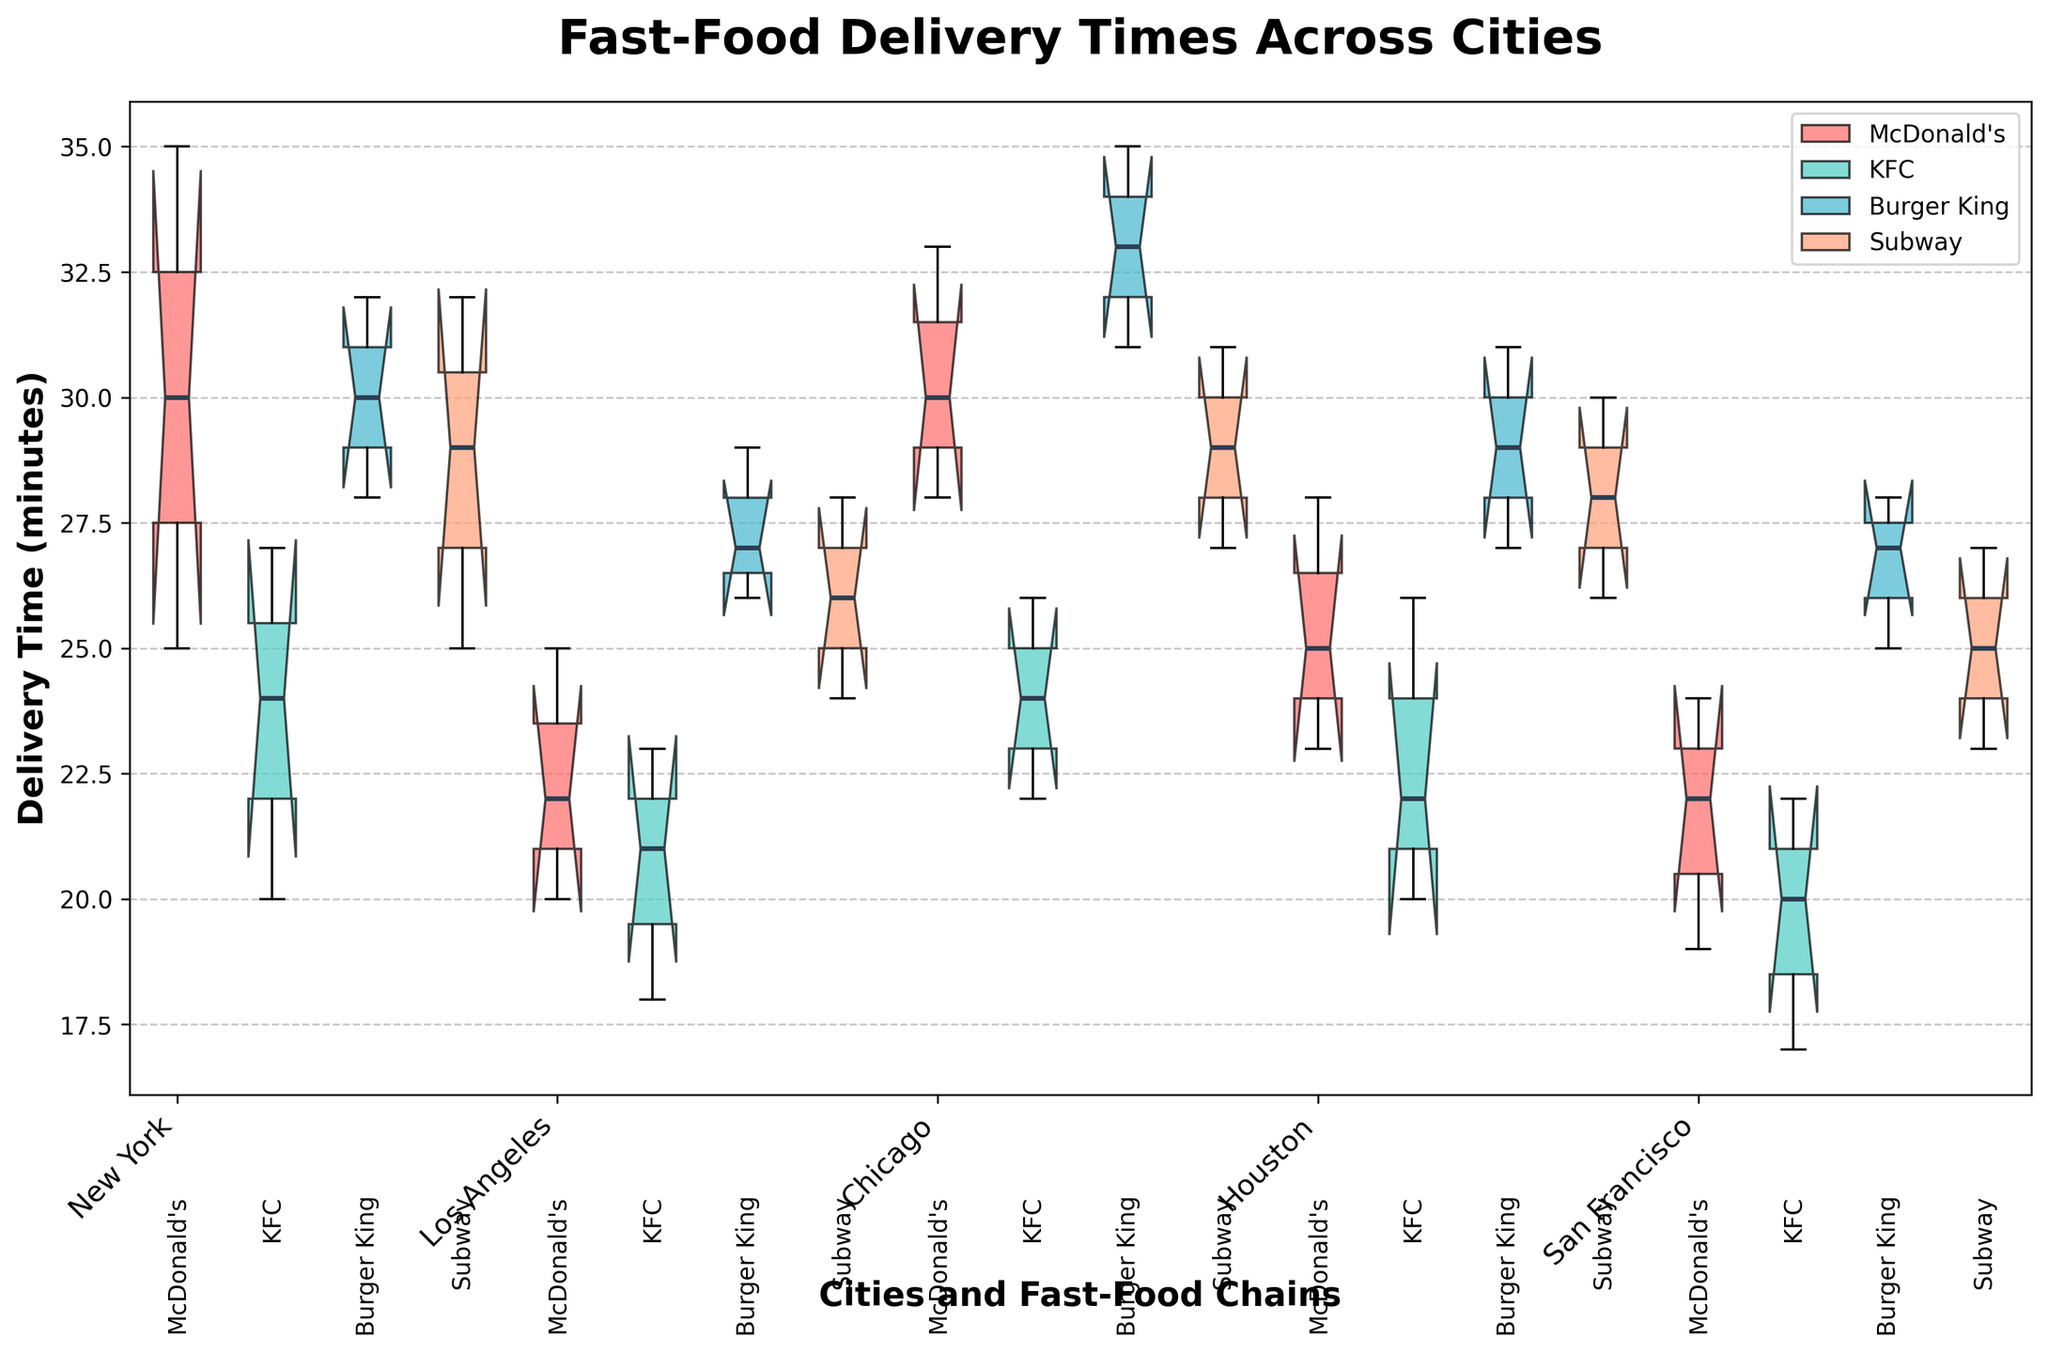What is the title of the figure? The title is usually prominently displayed at the top of the figure. In this case, the title is "Fast-Food Delivery Times Across Cities" as indicated in the code generating the plot.
Answer: Fast-Food Delivery Times Across Cities What does the y-axis represent? The y-axis typically displays the variable being measured. Here, it represents the delivery time in minutes, as specified with the label "Delivery Time (minutes)" in the code.
Answer: Delivery Time (minutes) How are the different fast-food chains distinguished in the plot? Different fast-food chains are distinguished by colors and labels. The code uses a custom color palette (red, cyan, blue, and orange) and labels each box plot with the respective chain name.
Answer: By colors and labels Which city shows the lowest median delivery time for McDonald's? The median is indicated by the line inside each box. The figure shows that San Francisco has the lowest median delivery time for McDonald's as its box plot is the lowest among those for McDonald's.
Answer: San Francisco Between which fast-food chains in New York does the delivery time show the most overlap? Overlap can be identified by looking at how much the notches of the box plots overlap. In New York, the delivery times for Burger King and McDonald's show significant overlap.
Answer: Burger King and McDonald's What is the general trend of delivery times for Subway across the cities? Look at the median lines within Subway's box plots for each city. The delivery times for Subway appear to have a slightly increasing trend from San Francisco to Chicago.
Answer: Increasing trend from San Francisco to Chicago Which city has the highest upper whisker for any fast-food chain? The upper whisker represents the maximum delivery time within 1.5 IQR. By visually inspecting the whiskers, we find that Chicago for Burger King has the highest upper whisker.
Answer: Chicago (Burger King) In which city does KFC have the most variability in delivery times? Variability is indicated by the length of the box and whiskers. Houston's box plot for KFC has the longest whiskers and the largest interquartile range (IQR), indicating the most variability.
Answer: Houston Which fast-food chain’s delivery time in Los Angeles has the smallest interquartile range (IQR)? The IQR is represented by the length of the box. For Los Angeles, McDonald's has the smallest box, indicating the smallest IQR.
Answer: McDonald's How does the median delivery time for Burger King in Los Angeles compare to Subway in Los Angeles? Compare the median lines within the box plots for both chains in Los Angeles. The median delivery time for Burger King is slightly higher than that for Subway in Los Angeles.
Answer: Higher 